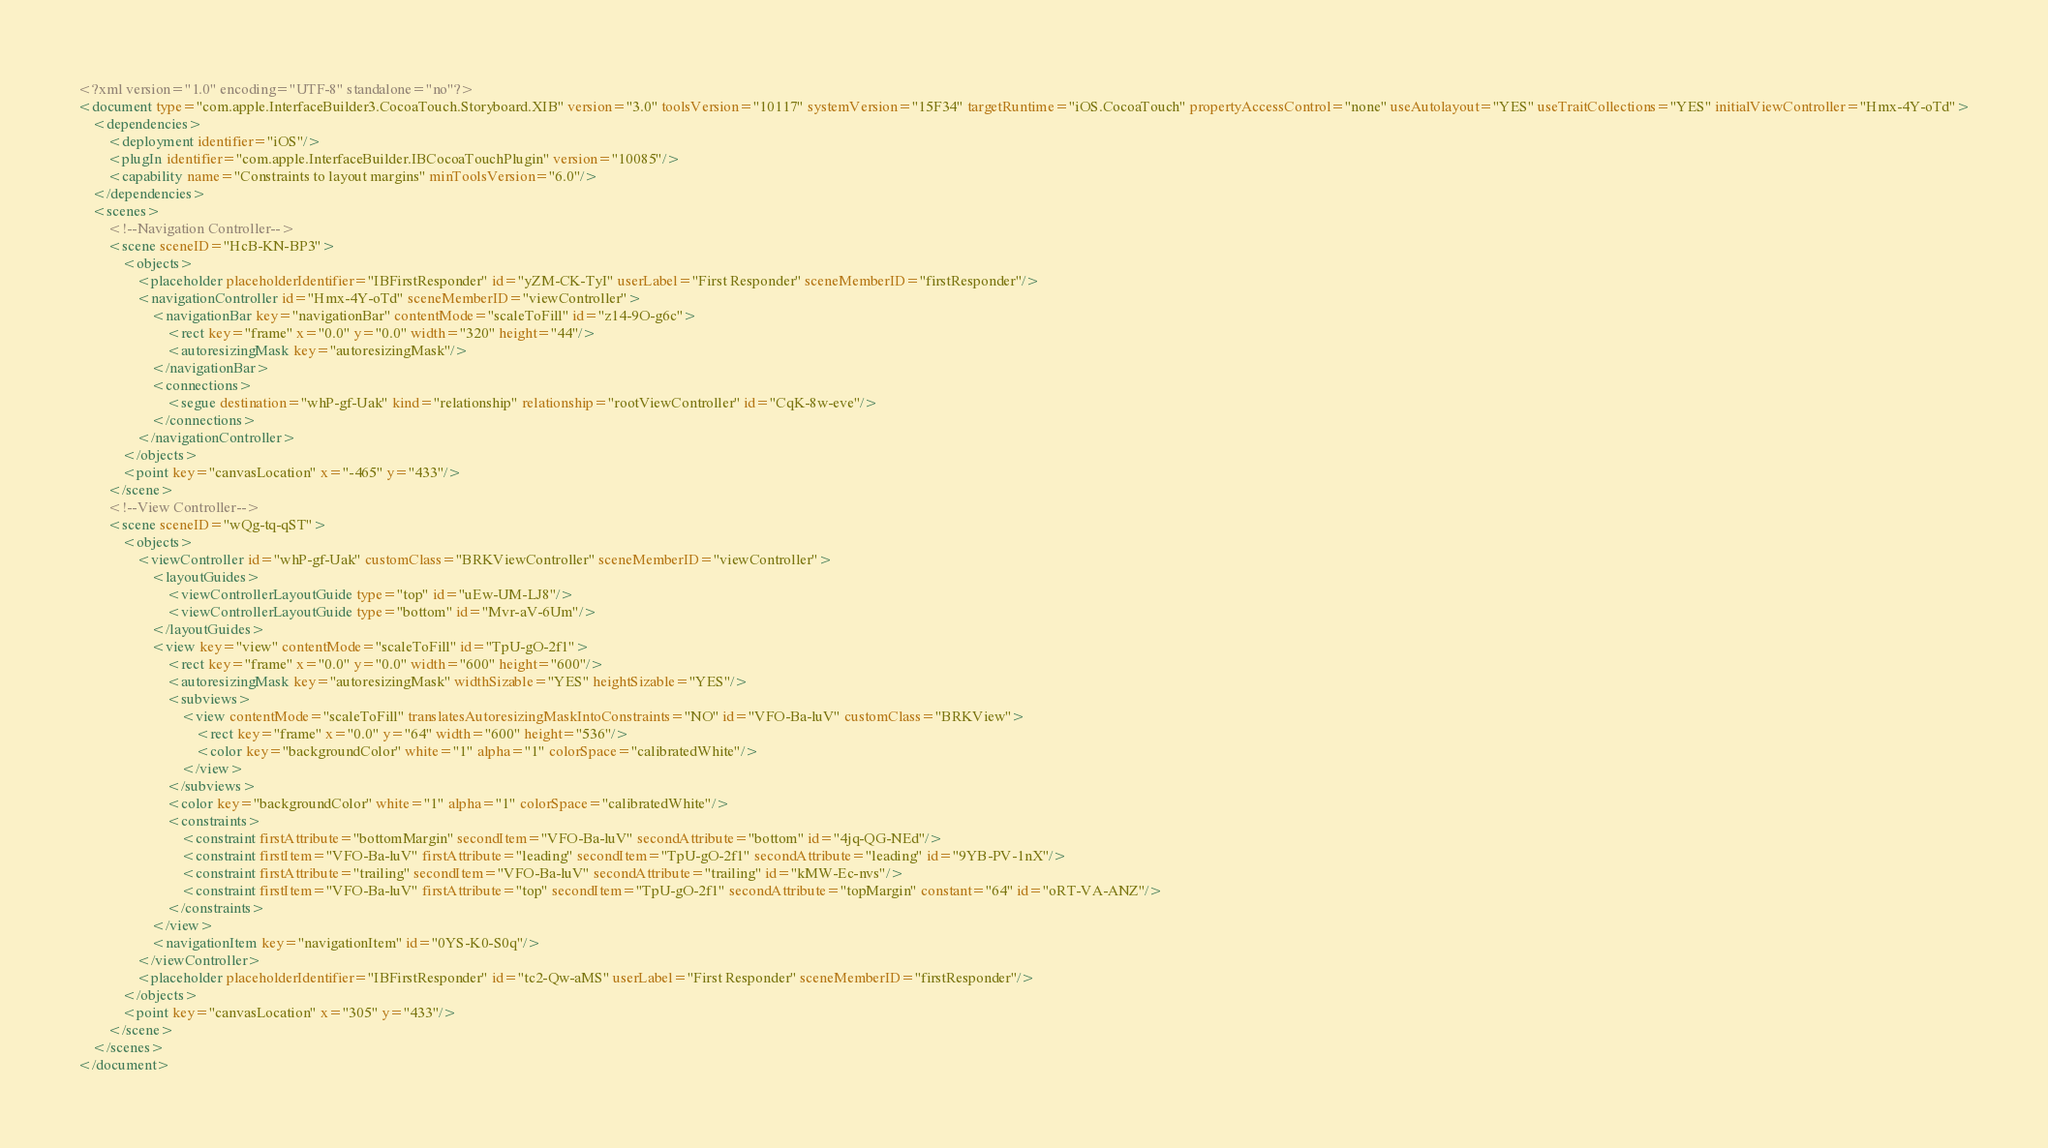<code> <loc_0><loc_0><loc_500><loc_500><_XML_><?xml version="1.0" encoding="UTF-8" standalone="no"?>
<document type="com.apple.InterfaceBuilder3.CocoaTouch.Storyboard.XIB" version="3.0" toolsVersion="10117" systemVersion="15F34" targetRuntime="iOS.CocoaTouch" propertyAccessControl="none" useAutolayout="YES" useTraitCollections="YES" initialViewController="Hmx-4Y-oTd">
    <dependencies>
        <deployment identifier="iOS"/>
        <plugIn identifier="com.apple.InterfaceBuilder.IBCocoaTouchPlugin" version="10085"/>
        <capability name="Constraints to layout margins" minToolsVersion="6.0"/>
    </dependencies>
    <scenes>
        <!--Navigation Controller-->
        <scene sceneID="HcB-KN-BP3">
            <objects>
                <placeholder placeholderIdentifier="IBFirstResponder" id="yZM-CK-TyI" userLabel="First Responder" sceneMemberID="firstResponder"/>
                <navigationController id="Hmx-4Y-oTd" sceneMemberID="viewController">
                    <navigationBar key="navigationBar" contentMode="scaleToFill" id="z14-9O-g6c">
                        <rect key="frame" x="0.0" y="0.0" width="320" height="44"/>
                        <autoresizingMask key="autoresizingMask"/>
                    </navigationBar>
                    <connections>
                        <segue destination="whP-gf-Uak" kind="relationship" relationship="rootViewController" id="CqK-8w-eve"/>
                    </connections>
                </navigationController>
            </objects>
            <point key="canvasLocation" x="-465" y="433"/>
        </scene>
        <!--View Controller-->
        <scene sceneID="wQg-tq-qST">
            <objects>
                <viewController id="whP-gf-Uak" customClass="BRKViewController" sceneMemberID="viewController">
                    <layoutGuides>
                        <viewControllerLayoutGuide type="top" id="uEw-UM-LJ8"/>
                        <viewControllerLayoutGuide type="bottom" id="Mvr-aV-6Um"/>
                    </layoutGuides>
                    <view key="view" contentMode="scaleToFill" id="TpU-gO-2f1">
                        <rect key="frame" x="0.0" y="0.0" width="600" height="600"/>
                        <autoresizingMask key="autoresizingMask" widthSizable="YES" heightSizable="YES"/>
                        <subviews>
                            <view contentMode="scaleToFill" translatesAutoresizingMaskIntoConstraints="NO" id="VFO-Ba-luV" customClass="BRKView">
                                <rect key="frame" x="0.0" y="64" width="600" height="536"/>
                                <color key="backgroundColor" white="1" alpha="1" colorSpace="calibratedWhite"/>
                            </view>
                        </subviews>
                        <color key="backgroundColor" white="1" alpha="1" colorSpace="calibratedWhite"/>
                        <constraints>
                            <constraint firstAttribute="bottomMargin" secondItem="VFO-Ba-luV" secondAttribute="bottom" id="4jq-QG-NEd"/>
                            <constraint firstItem="VFO-Ba-luV" firstAttribute="leading" secondItem="TpU-gO-2f1" secondAttribute="leading" id="9YB-PV-1nX"/>
                            <constraint firstAttribute="trailing" secondItem="VFO-Ba-luV" secondAttribute="trailing" id="kMW-Ec-nvs"/>
                            <constraint firstItem="VFO-Ba-luV" firstAttribute="top" secondItem="TpU-gO-2f1" secondAttribute="topMargin" constant="64" id="oRT-VA-ANZ"/>
                        </constraints>
                    </view>
                    <navigationItem key="navigationItem" id="0YS-K0-S0q"/>
                </viewController>
                <placeholder placeholderIdentifier="IBFirstResponder" id="tc2-Qw-aMS" userLabel="First Responder" sceneMemberID="firstResponder"/>
            </objects>
            <point key="canvasLocation" x="305" y="433"/>
        </scene>
    </scenes>
</document>
</code> 